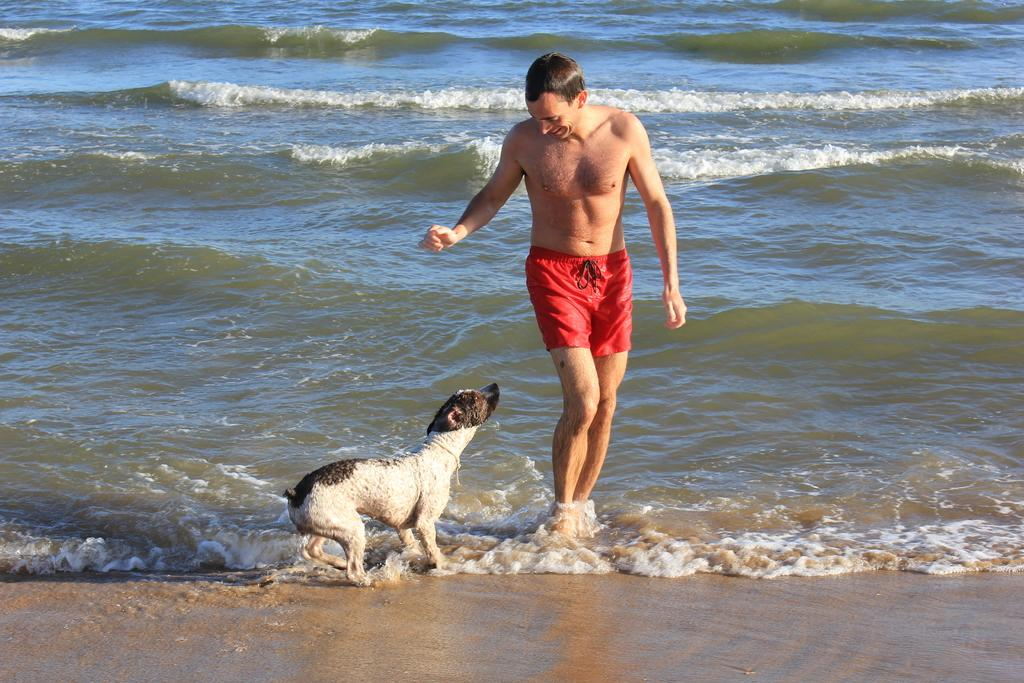Who is present in the image? There is a man in the image. What is the man wearing? The man is wearing red shorts. What is the man doing in the image? The man is standing and looking at a dog. Can you describe the dog in the image? The dog is white and black. What can be seen in the background of the image? There are water waves visible in the background of the image. Is the girl in the image wearing a yellow dress? There is no girl present in the image, only a man and a dog. Can you tell me how the man slips on the wet floor in the image? There is no mention of a wet floor or the man slipping in the image; he is standing and looking at the dog. 